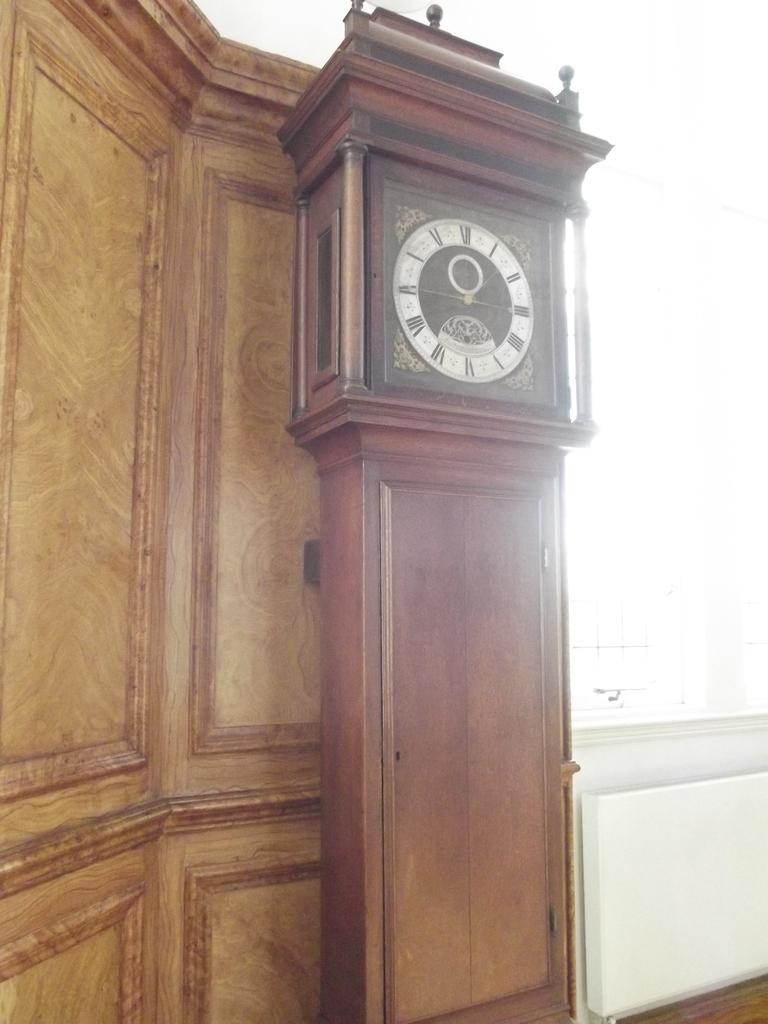Can you describe this image briefly? In the middle of the picture, we see the clock. Behind that, we see a cupboard. In the right bottom of the picture, we see something in white color. On the right side, it is white in color. 